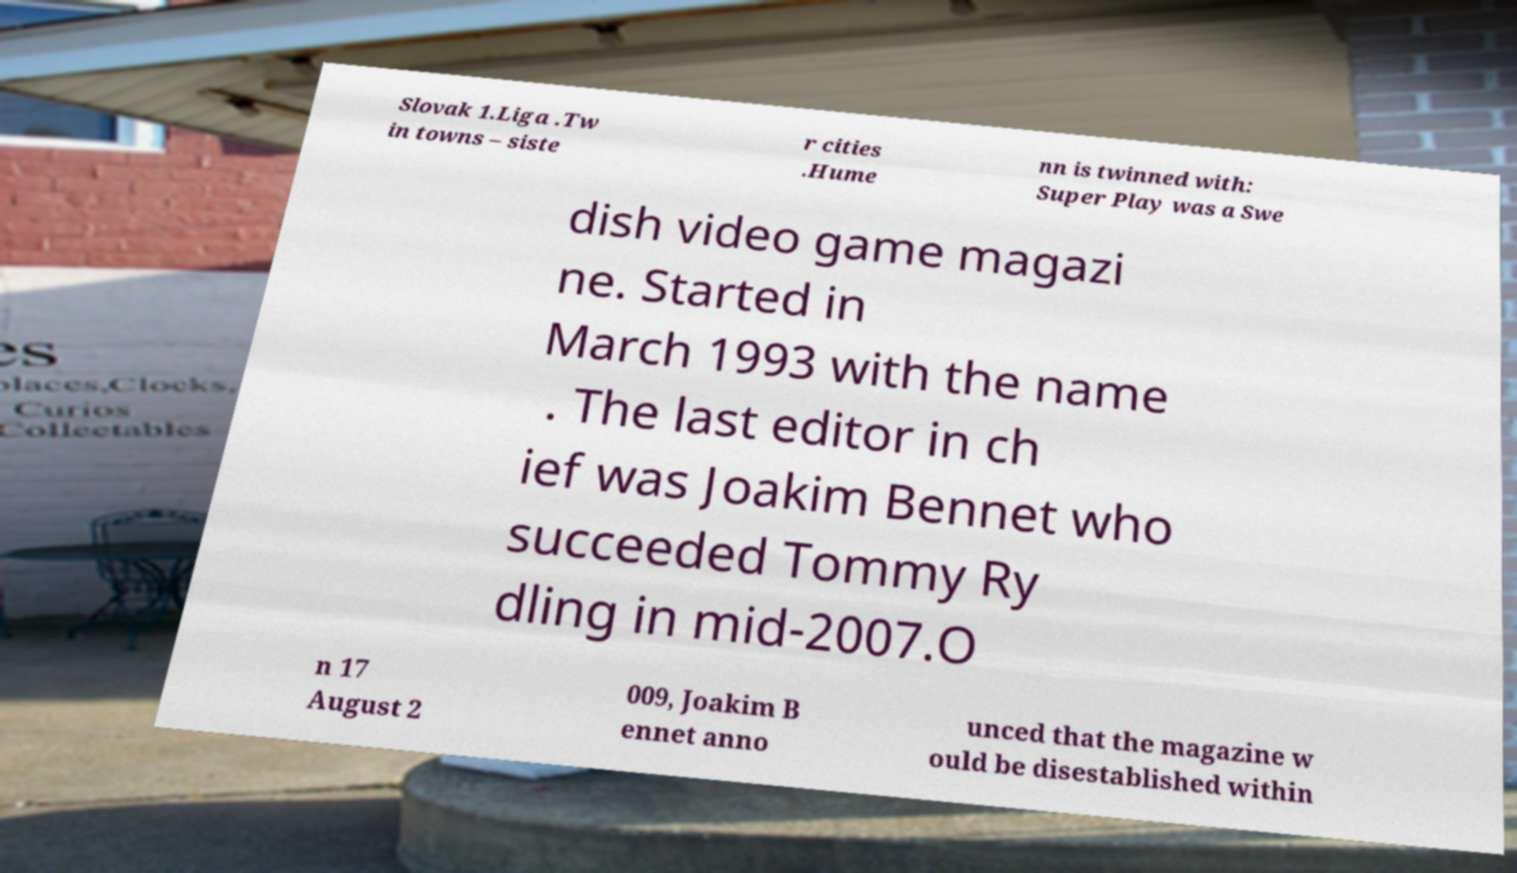Can you read and provide the text displayed in the image?This photo seems to have some interesting text. Can you extract and type it out for me? Slovak 1.Liga .Tw in towns – siste r cities .Hume nn is twinned with: Super Play was a Swe dish video game magazi ne. Started in March 1993 with the name . The last editor in ch ief was Joakim Bennet who succeeded Tommy Ry dling in mid-2007.O n 17 August 2 009, Joakim B ennet anno unced that the magazine w ould be disestablished within 